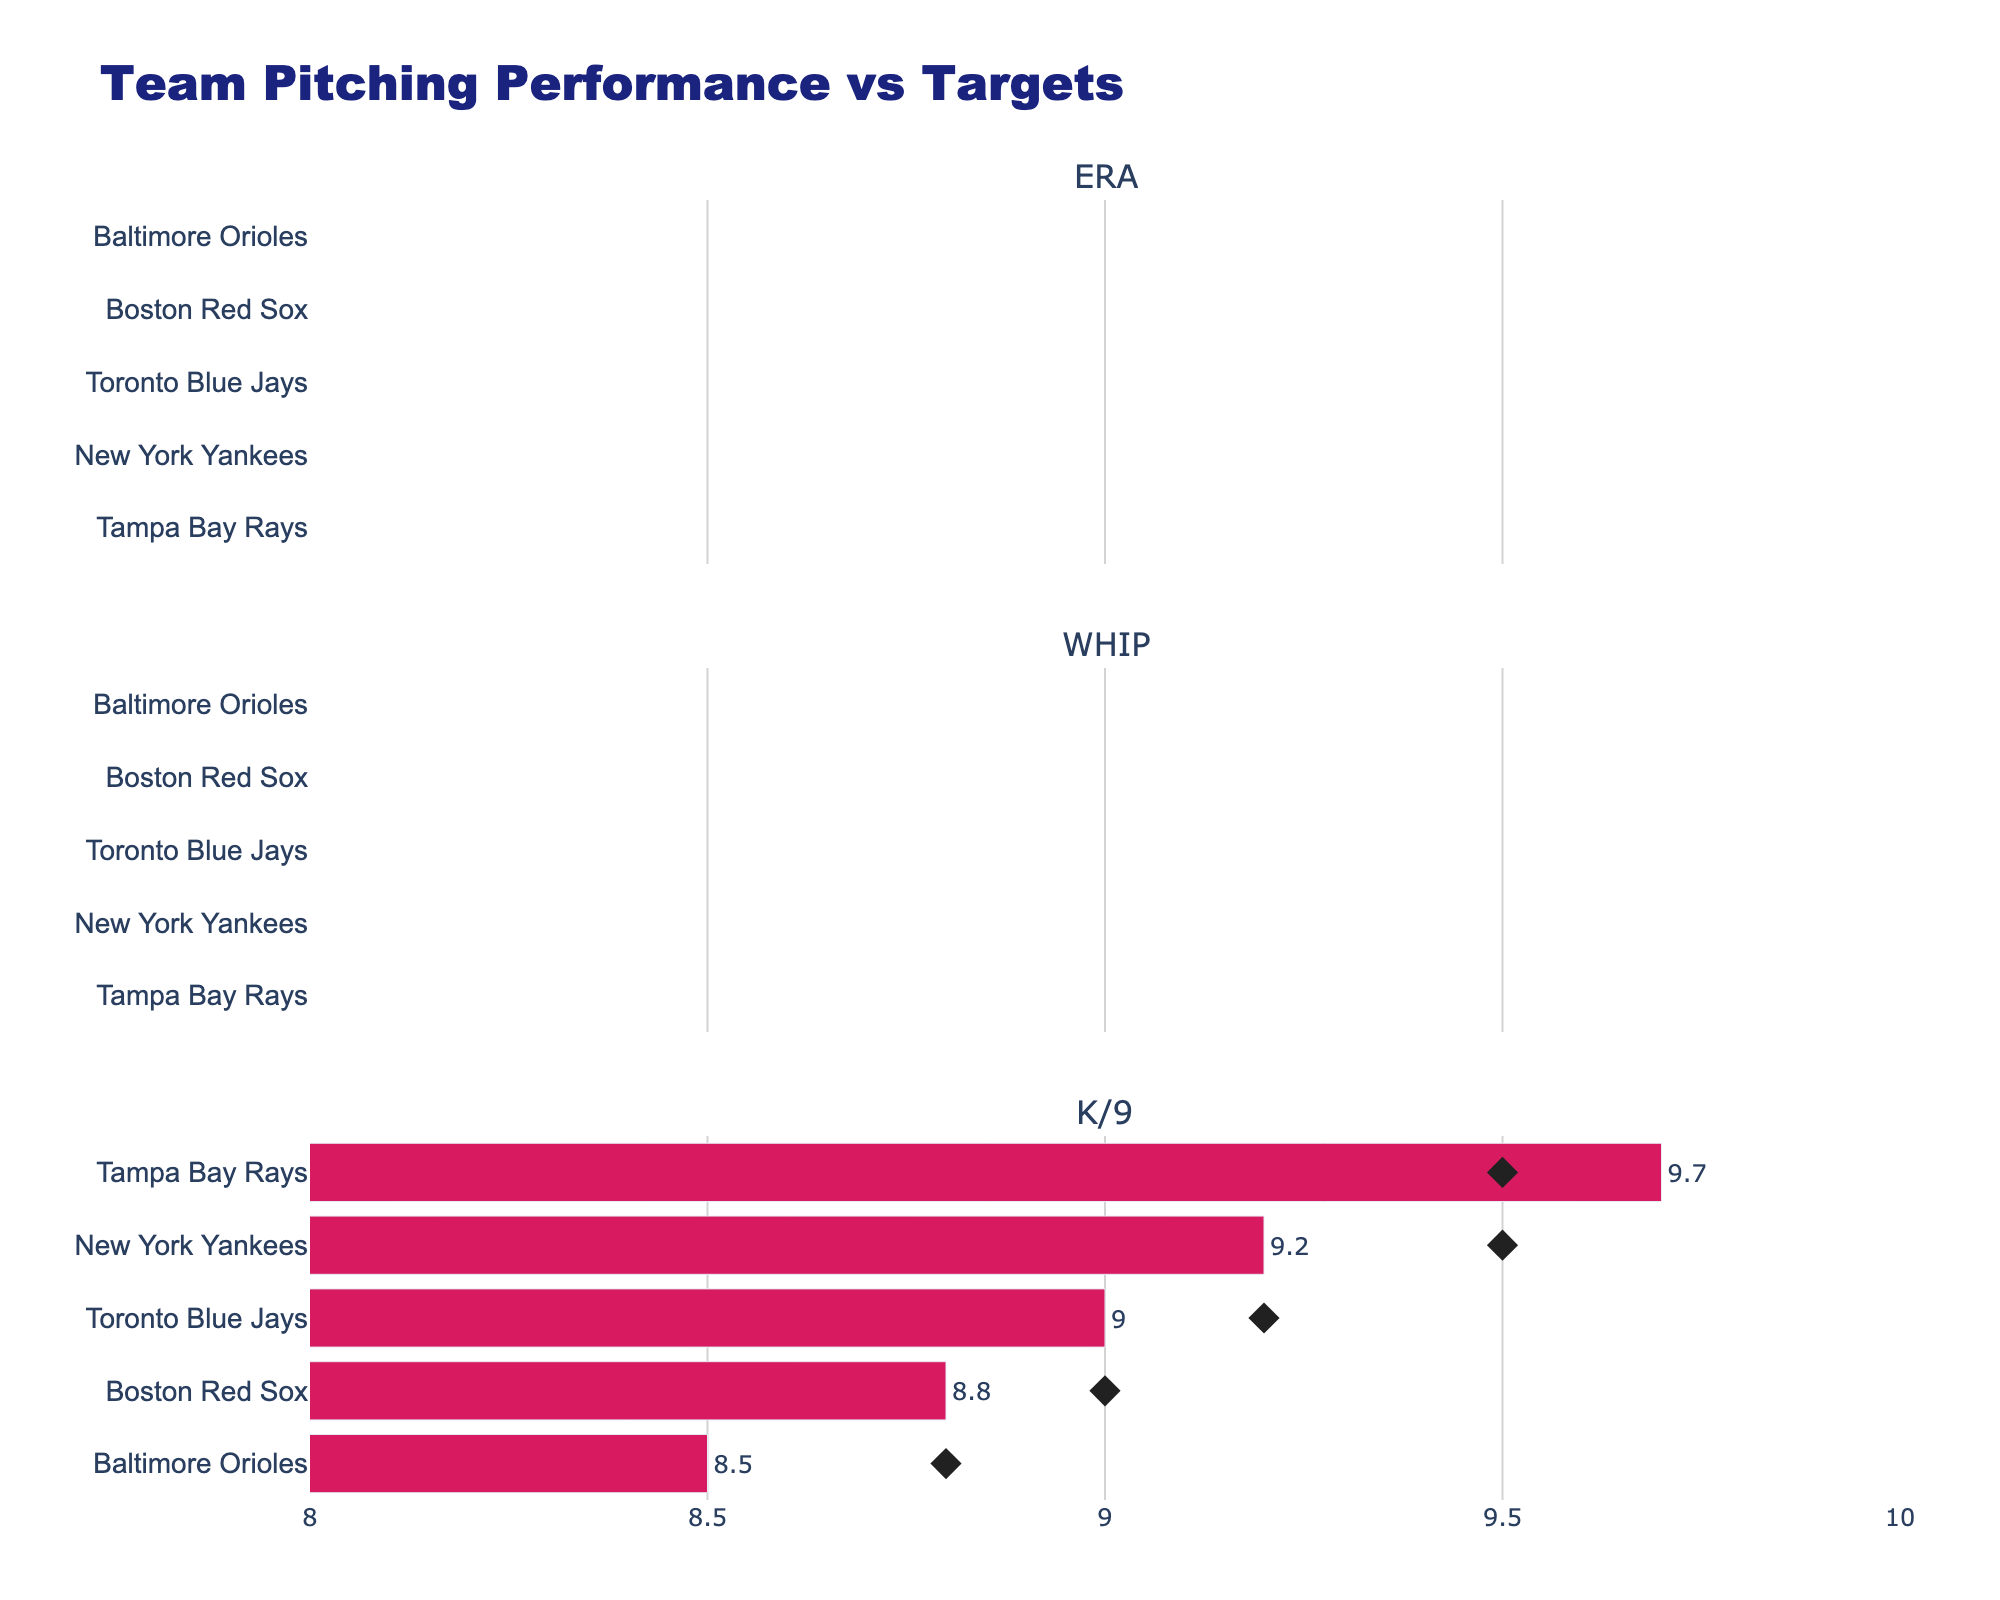What's the target ERA for the New York Yankees? The bullet chart shows the ERA values for each team alongside their respective targets. For the New York Yankees, the target ERA is indicated by a diamond symbol.
Answer: 3.50 Which team has the worst WHIP performance compared to their target? By looking at the WHIP values and their corresponding targets, the team farthest from achieving its target has the worst performance. The Baltimore Orioles have a WHIP of 1.35 with a target of 1.25, the largest discrepancy.
Answer: Baltimore Orioles How many teams have exceeded their K/9 targets? Comparing the K/9 performance values with their targets for each team, we see that only the Tampa Bay Rays (9.7 vs 9.5) have exceeded their K/9 targets.
Answer: One team What's the difference between the actual and target ERA for the Boston Red Sox? Subtract the actual ERA from the target ERA for the Boston Red Sox: 4.10 - 3.80 = 0.30.
Answer: 0.30 Which team is closest to meeting its WHIP target? The chart indicates the actual WHIP values and targets. The Tampa Bay Rays show the smallest deviation from their target WHIP, with an actual of 1.15 and a target of 1.10.
Answer: Tampa Bay Rays Rank the teams based on their ERA from best to worst. By comparing the ERA values for all teams, the ranking from best to worst is: Tampa Bay Rays (3.40), New York Yankees (3.65), Toronto Blue Jays (3.85), Boston Red Sox (4.10), Baltimore Orioles (4.25).
Answer: Tampa Bay Rays, New York Yankees, Toronto Blue Jays, Boston Red Sox, Baltimore Orioles For which pitching metric are all teams falling short of their targets? By checking each pitching metric (ERA, WHIP, K/9) against the targets, we see that no team has achieved their target ERA or WHIP. Multiple teams achieve their K/9 targets.
Answer: ERA and WHIP What is the average K/9 for the entire division? Add the K/9 values for all teams and divide by the number of teams: (9.2 + 8.8 + 9.7 + 9.0 + 8.5) / 5 = 9.04.
Answer: 9.04 